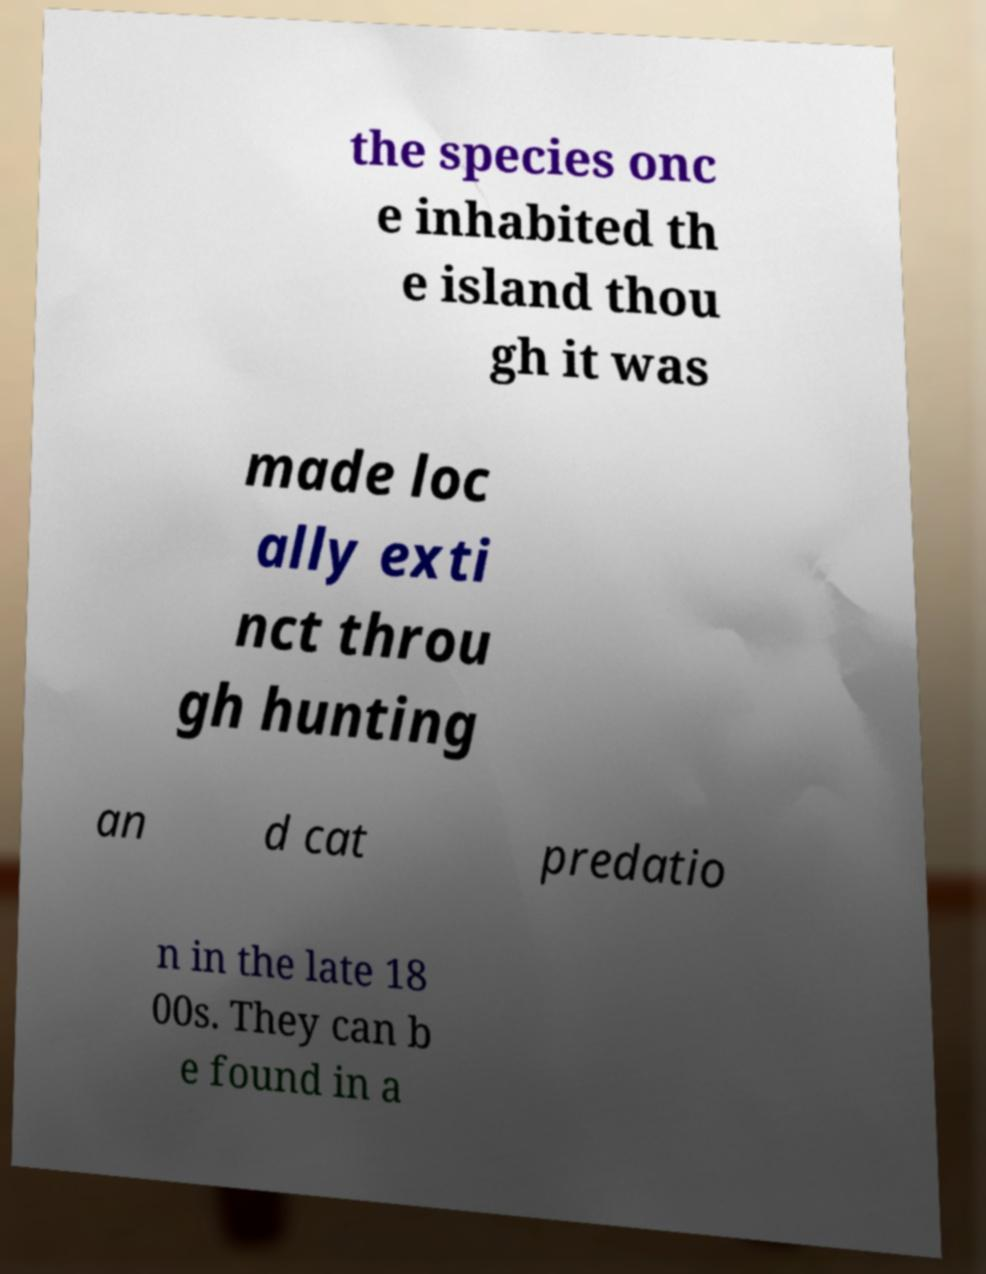Could you extract and type out the text from this image? the species onc e inhabited th e island thou gh it was made loc ally exti nct throu gh hunting an d cat predatio n in the late 18 00s. They can b e found in a 